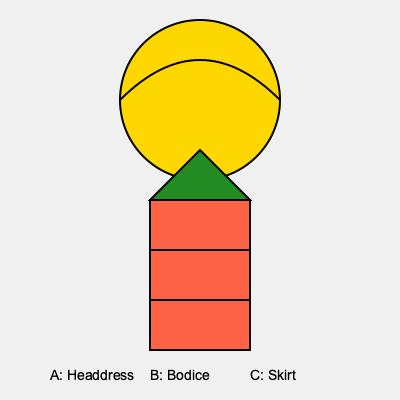Analyze the visual elements and symbolism in this Filipino folk dance costume diagram. Which component represents the connection between earth and sky in Filipino mythology, and how does its design reflect this symbolism? To answer this question, we need to examine each component of the costume and its symbolic significance in Filipino culture:

1. Headdress (A): The circular shape at the top represents the sun, a common motif in Filipino mythology. Its golden color symbolizes abundance and divinity.

2. Bodice (B): The red rectangular shape represents the body of the dancer. Red is often associated with life and vitality in Filipino culture.

3. Skirt (C): The green triangular shape at the top of the skirt represents mountains or fertility.

4. Lines on the skirt: These horizontal lines could represent layers or tiers, common in traditional Filipino clothing.

The component that represents the connection between earth and sky is the headdress (A). This interpretation is based on the following aspects:

1. Shape: The semi-circular arc above the circular sun shape resembles a rainbow, which in many cultures, including Filipino, is seen as a bridge between earth and sky.

2. Position: The headdress is placed at the top of the costume, symbolizing its proximity to the heavens.

3. Color: The golden color of the headdress represents the sun, a celestial body that influences both the sky and the earth.

4. Cultural context: In Filipino mythology, the sun god Apolaki is often associated with the sky, while his sister Mayari is associated with the earth. The headdress, symbolizing the sun, can be seen as a link between these realms.

The design reflects this symbolism through its arched shape, reminiscent of a rainbow or the sun's arc across the sky, and its placement atop the entire costume, emphasizing its role as a connector between the earthly (represented by the bodice and skirt) and the celestial.
Answer: The headdress (A), representing a sun and rainbow, symbolizes the connection between earth and sky through its arched shape and top placement. 